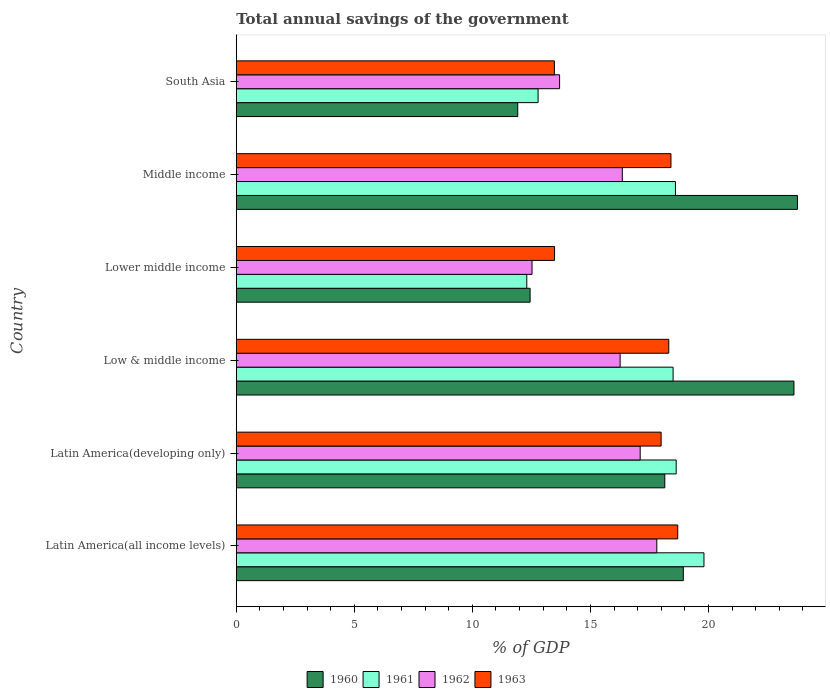How many groups of bars are there?
Offer a terse response. 6. Are the number of bars on each tick of the Y-axis equal?
Provide a short and direct response. Yes. How many bars are there on the 5th tick from the top?
Provide a short and direct response. 4. How many bars are there on the 1st tick from the bottom?
Offer a very short reply. 4. In how many cases, is the number of bars for a given country not equal to the number of legend labels?
Your answer should be very brief. 0. What is the total annual savings of the government in 1961 in Latin America(developing only)?
Give a very brief answer. 18.63. Across all countries, what is the maximum total annual savings of the government in 1963?
Provide a short and direct response. 18.7. Across all countries, what is the minimum total annual savings of the government in 1962?
Offer a terse response. 12.53. In which country was the total annual savings of the government in 1962 minimum?
Make the answer very short. Lower middle income. What is the total total annual savings of the government in 1963 in the graph?
Your answer should be compact. 100.38. What is the difference between the total annual savings of the government in 1963 in Latin America(all income levels) and that in Low & middle income?
Provide a short and direct response. 0.38. What is the difference between the total annual savings of the government in 1960 in Latin America(developing only) and the total annual savings of the government in 1961 in Lower middle income?
Your response must be concise. 5.85. What is the average total annual savings of the government in 1963 per country?
Provide a succinct answer. 16.73. What is the difference between the total annual savings of the government in 1960 and total annual savings of the government in 1963 in Low & middle income?
Offer a terse response. 5.3. In how many countries, is the total annual savings of the government in 1960 greater than 1 %?
Ensure brevity in your answer.  6. What is the ratio of the total annual savings of the government in 1963 in Lower middle income to that in Middle income?
Offer a very short reply. 0.73. What is the difference between the highest and the second highest total annual savings of the government in 1963?
Your answer should be compact. 0.29. What is the difference between the highest and the lowest total annual savings of the government in 1960?
Keep it short and to the point. 11.85. Is the sum of the total annual savings of the government in 1960 in Latin America(all income levels) and Latin America(developing only) greater than the maximum total annual savings of the government in 1962 across all countries?
Offer a very short reply. Yes. What does the 1st bar from the top in Latin America(all income levels) represents?
Your response must be concise. 1963. What does the 2nd bar from the bottom in Lower middle income represents?
Ensure brevity in your answer.  1961. Is it the case that in every country, the sum of the total annual savings of the government in 1962 and total annual savings of the government in 1963 is greater than the total annual savings of the government in 1960?
Offer a very short reply. Yes. How many countries are there in the graph?
Provide a short and direct response. 6. What is the difference between two consecutive major ticks on the X-axis?
Your answer should be compact. 5. Are the values on the major ticks of X-axis written in scientific E-notation?
Provide a short and direct response. No. Does the graph contain any zero values?
Provide a succinct answer. No. Does the graph contain grids?
Your answer should be very brief. No. Where does the legend appear in the graph?
Provide a succinct answer. Bottom center. How many legend labels are there?
Keep it short and to the point. 4. How are the legend labels stacked?
Your response must be concise. Horizontal. What is the title of the graph?
Your answer should be compact. Total annual savings of the government. Does "1960" appear as one of the legend labels in the graph?
Make the answer very short. Yes. What is the label or title of the X-axis?
Give a very brief answer. % of GDP. What is the label or title of the Y-axis?
Your response must be concise. Country. What is the % of GDP of 1960 in Latin America(all income levels)?
Your answer should be compact. 18.93. What is the % of GDP of 1961 in Latin America(all income levels)?
Make the answer very short. 19.81. What is the % of GDP of 1962 in Latin America(all income levels)?
Ensure brevity in your answer.  17.81. What is the % of GDP in 1963 in Latin America(all income levels)?
Give a very brief answer. 18.7. What is the % of GDP in 1960 in Latin America(developing only)?
Give a very brief answer. 18.15. What is the % of GDP of 1961 in Latin America(developing only)?
Your response must be concise. 18.63. What is the % of GDP of 1962 in Latin America(developing only)?
Offer a terse response. 17.11. What is the % of GDP of 1963 in Latin America(developing only)?
Give a very brief answer. 17.99. What is the % of GDP in 1960 in Low & middle income?
Offer a terse response. 23.62. What is the % of GDP of 1961 in Low & middle income?
Make the answer very short. 18.5. What is the % of GDP in 1962 in Low & middle income?
Provide a short and direct response. 16.26. What is the % of GDP of 1963 in Low & middle income?
Your answer should be compact. 18.32. What is the % of GDP of 1960 in Lower middle income?
Ensure brevity in your answer.  12.45. What is the % of GDP in 1961 in Lower middle income?
Your answer should be compact. 12.3. What is the % of GDP in 1962 in Lower middle income?
Offer a terse response. 12.53. What is the % of GDP of 1963 in Lower middle income?
Provide a succinct answer. 13.48. What is the % of GDP of 1960 in Middle income?
Ensure brevity in your answer.  23.77. What is the % of GDP of 1961 in Middle income?
Provide a succinct answer. 18.6. What is the % of GDP of 1962 in Middle income?
Offer a very short reply. 16.35. What is the % of GDP in 1963 in Middle income?
Ensure brevity in your answer.  18.41. What is the % of GDP in 1960 in South Asia?
Provide a short and direct response. 11.92. What is the % of GDP of 1961 in South Asia?
Provide a succinct answer. 12.78. What is the % of GDP of 1962 in South Asia?
Give a very brief answer. 13.69. What is the % of GDP of 1963 in South Asia?
Make the answer very short. 13.48. Across all countries, what is the maximum % of GDP in 1960?
Your response must be concise. 23.77. Across all countries, what is the maximum % of GDP in 1961?
Give a very brief answer. 19.81. Across all countries, what is the maximum % of GDP in 1962?
Ensure brevity in your answer.  17.81. Across all countries, what is the maximum % of GDP in 1963?
Provide a short and direct response. 18.7. Across all countries, what is the minimum % of GDP of 1960?
Offer a terse response. 11.92. Across all countries, what is the minimum % of GDP of 1961?
Give a very brief answer. 12.3. Across all countries, what is the minimum % of GDP in 1962?
Offer a very short reply. 12.53. Across all countries, what is the minimum % of GDP in 1963?
Your answer should be very brief. 13.48. What is the total % of GDP of 1960 in the graph?
Ensure brevity in your answer.  108.84. What is the total % of GDP of 1961 in the graph?
Ensure brevity in your answer.  100.64. What is the total % of GDP in 1962 in the graph?
Your response must be concise. 93.75. What is the total % of GDP of 1963 in the graph?
Keep it short and to the point. 100.38. What is the difference between the % of GDP of 1960 in Latin America(all income levels) and that in Latin America(developing only)?
Your answer should be compact. 0.78. What is the difference between the % of GDP of 1961 in Latin America(all income levels) and that in Latin America(developing only)?
Make the answer very short. 1.18. What is the difference between the % of GDP of 1962 in Latin America(all income levels) and that in Latin America(developing only)?
Offer a very short reply. 0.7. What is the difference between the % of GDP in 1963 in Latin America(all income levels) and that in Latin America(developing only)?
Keep it short and to the point. 0.7. What is the difference between the % of GDP of 1960 in Latin America(all income levels) and that in Low & middle income?
Provide a succinct answer. -4.69. What is the difference between the % of GDP of 1961 in Latin America(all income levels) and that in Low & middle income?
Offer a terse response. 1.31. What is the difference between the % of GDP in 1962 in Latin America(all income levels) and that in Low & middle income?
Your answer should be very brief. 1.55. What is the difference between the % of GDP of 1963 in Latin America(all income levels) and that in Low & middle income?
Your answer should be very brief. 0.38. What is the difference between the % of GDP in 1960 in Latin America(all income levels) and that in Lower middle income?
Give a very brief answer. 6.49. What is the difference between the % of GDP in 1961 in Latin America(all income levels) and that in Lower middle income?
Keep it short and to the point. 7.5. What is the difference between the % of GDP in 1962 in Latin America(all income levels) and that in Lower middle income?
Provide a succinct answer. 5.28. What is the difference between the % of GDP of 1963 in Latin America(all income levels) and that in Lower middle income?
Keep it short and to the point. 5.22. What is the difference between the % of GDP in 1960 in Latin America(all income levels) and that in Middle income?
Your answer should be very brief. -4.83. What is the difference between the % of GDP in 1961 in Latin America(all income levels) and that in Middle income?
Your answer should be very brief. 1.21. What is the difference between the % of GDP in 1962 in Latin America(all income levels) and that in Middle income?
Offer a terse response. 1.46. What is the difference between the % of GDP in 1963 in Latin America(all income levels) and that in Middle income?
Your answer should be very brief. 0.29. What is the difference between the % of GDP in 1960 in Latin America(all income levels) and that in South Asia?
Keep it short and to the point. 7.01. What is the difference between the % of GDP in 1961 in Latin America(all income levels) and that in South Asia?
Offer a terse response. 7.03. What is the difference between the % of GDP of 1962 in Latin America(all income levels) and that in South Asia?
Give a very brief answer. 4.12. What is the difference between the % of GDP in 1963 in Latin America(all income levels) and that in South Asia?
Make the answer very short. 5.22. What is the difference between the % of GDP in 1960 in Latin America(developing only) and that in Low & middle income?
Keep it short and to the point. -5.47. What is the difference between the % of GDP in 1961 in Latin America(developing only) and that in Low & middle income?
Your answer should be very brief. 0.13. What is the difference between the % of GDP of 1962 in Latin America(developing only) and that in Low & middle income?
Your response must be concise. 0.85. What is the difference between the % of GDP in 1963 in Latin America(developing only) and that in Low & middle income?
Keep it short and to the point. -0.32. What is the difference between the % of GDP of 1960 in Latin America(developing only) and that in Lower middle income?
Your response must be concise. 5.7. What is the difference between the % of GDP in 1961 in Latin America(developing only) and that in Lower middle income?
Your answer should be very brief. 6.33. What is the difference between the % of GDP of 1962 in Latin America(developing only) and that in Lower middle income?
Your answer should be compact. 4.58. What is the difference between the % of GDP of 1963 in Latin America(developing only) and that in Lower middle income?
Your answer should be very brief. 4.51. What is the difference between the % of GDP of 1960 in Latin America(developing only) and that in Middle income?
Offer a very short reply. -5.62. What is the difference between the % of GDP in 1961 in Latin America(developing only) and that in Middle income?
Keep it short and to the point. 0.03. What is the difference between the % of GDP of 1962 in Latin America(developing only) and that in Middle income?
Make the answer very short. 0.76. What is the difference between the % of GDP in 1963 in Latin America(developing only) and that in Middle income?
Provide a succinct answer. -0.42. What is the difference between the % of GDP of 1960 in Latin America(developing only) and that in South Asia?
Provide a succinct answer. 6.23. What is the difference between the % of GDP of 1961 in Latin America(developing only) and that in South Asia?
Your answer should be very brief. 5.85. What is the difference between the % of GDP in 1962 in Latin America(developing only) and that in South Asia?
Make the answer very short. 3.41. What is the difference between the % of GDP in 1963 in Latin America(developing only) and that in South Asia?
Give a very brief answer. 4.52. What is the difference between the % of GDP of 1960 in Low & middle income and that in Lower middle income?
Offer a very short reply. 11.18. What is the difference between the % of GDP in 1961 in Low & middle income and that in Lower middle income?
Your response must be concise. 6.2. What is the difference between the % of GDP of 1962 in Low & middle income and that in Lower middle income?
Your answer should be very brief. 3.73. What is the difference between the % of GDP in 1963 in Low & middle income and that in Lower middle income?
Your answer should be compact. 4.84. What is the difference between the % of GDP in 1960 in Low & middle income and that in Middle income?
Provide a succinct answer. -0.15. What is the difference between the % of GDP in 1961 in Low & middle income and that in Middle income?
Make the answer very short. -0.1. What is the difference between the % of GDP in 1962 in Low & middle income and that in Middle income?
Your response must be concise. -0.09. What is the difference between the % of GDP of 1963 in Low & middle income and that in Middle income?
Ensure brevity in your answer.  -0.09. What is the difference between the % of GDP in 1960 in Low & middle income and that in South Asia?
Provide a short and direct response. 11.7. What is the difference between the % of GDP in 1961 in Low & middle income and that in South Asia?
Your response must be concise. 5.72. What is the difference between the % of GDP of 1962 in Low & middle income and that in South Asia?
Keep it short and to the point. 2.56. What is the difference between the % of GDP of 1963 in Low & middle income and that in South Asia?
Give a very brief answer. 4.84. What is the difference between the % of GDP in 1960 in Lower middle income and that in Middle income?
Provide a short and direct response. -11.32. What is the difference between the % of GDP of 1961 in Lower middle income and that in Middle income?
Give a very brief answer. -6.3. What is the difference between the % of GDP in 1962 in Lower middle income and that in Middle income?
Provide a short and direct response. -3.82. What is the difference between the % of GDP in 1963 in Lower middle income and that in Middle income?
Your answer should be very brief. -4.93. What is the difference between the % of GDP of 1960 in Lower middle income and that in South Asia?
Offer a very short reply. 0.52. What is the difference between the % of GDP of 1961 in Lower middle income and that in South Asia?
Provide a succinct answer. -0.48. What is the difference between the % of GDP of 1962 in Lower middle income and that in South Asia?
Keep it short and to the point. -1.17. What is the difference between the % of GDP in 1963 in Lower middle income and that in South Asia?
Offer a very short reply. 0.01. What is the difference between the % of GDP in 1960 in Middle income and that in South Asia?
Your response must be concise. 11.85. What is the difference between the % of GDP in 1961 in Middle income and that in South Asia?
Your response must be concise. 5.82. What is the difference between the % of GDP in 1962 in Middle income and that in South Asia?
Provide a short and direct response. 2.66. What is the difference between the % of GDP in 1963 in Middle income and that in South Asia?
Keep it short and to the point. 4.94. What is the difference between the % of GDP of 1960 in Latin America(all income levels) and the % of GDP of 1961 in Latin America(developing only)?
Ensure brevity in your answer.  0.3. What is the difference between the % of GDP in 1960 in Latin America(all income levels) and the % of GDP in 1962 in Latin America(developing only)?
Your answer should be very brief. 1.83. What is the difference between the % of GDP of 1960 in Latin America(all income levels) and the % of GDP of 1963 in Latin America(developing only)?
Your response must be concise. 0.94. What is the difference between the % of GDP of 1961 in Latin America(all income levels) and the % of GDP of 1962 in Latin America(developing only)?
Ensure brevity in your answer.  2.7. What is the difference between the % of GDP in 1961 in Latin America(all income levels) and the % of GDP in 1963 in Latin America(developing only)?
Your answer should be very brief. 1.81. What is the difference between the % of GDP in 1962 in Latin America(all income levels) and the % of GDP in 1963 in Latin America(developing only)?
Your answer should be very brief. -0.18. What is the difference between the % of GDP of 1960 in Latin America(all income levels) and the % of GDP of 1961 in Low & middle income?
Provide a short and direct response. 0.43. What is the difference between the % of GDP in 1960 in Latin America(all income levels) and the % of GDP in 1962 in Low & middle income?
Your answer should be very brief. 2.68. What is the difference between the % of GDP in 1960 in Latin America(all income levels) and the % of GDP in 1963 in Low & middle income?
Give a very brief answer. 0.62. What is the difference between the % of GDP in 1961 in Latin America(all income levels) and the % of GDP in 1962 in Low & middle income?
Ensure brevity in your answer.  3.55. What is the difference between the % of GDP of 1961 in Latin America(all income levels) and the % of GDP of 1963 in Low & middle income?
Your answer should be compact. 1.49. What is the difference between the % of GDP of 1962 in Latin America(all income levels) and the % of GDP of 1963 in Low & middle income?
Provide a short and direct response. -0.51. What is the difference between the % of GDP of 1960 in Latin America(all income levels) and the % of GDP of 1961 in Lower middle income?
Provide a succinct answer. 6.63. What is the difference between the % of GDP in 1960 in Latin America(all income levels) and the % of GDP in 1962 in Lower middle income?
Keep it short and to the point. 6.41. What is the difference between the % of GDP of 1960 in Latin America(all income levels) and the % of GDP of 1963 in Lower middle income?
Provide a short and direct response. 5.45. What is the difference between the % of GDP in 1961 in Latin America(all income levels) and the % of GDP in 1962 in Lower middle income?
Offer a terse response. 7.28. What is the difference between the % of GDP in 1961 in Latin America(all income levels) and the % of GDP in 1963 in Lower middle income?
Keep it short and to the point. 6.33. What is the difference between the % of GDP in 1962 in Latin America(all income levels) and the % of GDP in 1963 in Lower middle income?
Make the answer very short. 4.33. What is the difference between the % of GDP of 1960 in Latin America(all income levels) and the % of GDP of 1961 in Middle income?
Your response must be concise. 0.33. What is the difference between the % of GDP of 1960 in Latin America(all income levels) and the % of GDP of 1962 in Middle income?
Provide a short and direct response. 2.58. What is the difference between the % of GDP in 1960 in Latin America(all income levels) and the % of GDP in 1963 in Middle income?
Ensure brevity in your answer.  0.52. What is the difference between the % of GDP of 1961 in Latin America(all income levels) and the % of GDP of 1962 in Middle income?
Your answer should be compact. 3.46. What is the difference between the % of GDP in 1961 in Latin America(all income levels) and the % of GDP in 1963 in Middle income?
Make the answer very short. 1.4. What is the difference between the % of GDP of 1962 in Latin America(all income levels) and the % of GDP of 1963 in Middle income?
Your answer should be compact. -0.6. What is the difference between the % of GDP of 1960 in Latin America(all income levels) and the % of GDP of 1961 in South Asia?
Provide a short and direct response. 6.15. What is the difference between the % of GDP in 1960 in Latin America(all income levels) and the % of GDP in 1962 in South Asia?
Ensure brevity in your answer.  5.24. What is the difference between the % of GDP of 1960 in Latin America(all income levels) and the % of GDP of 1963 in South Asia?
Make the answer very short. 5.46. What is the difference between the % of GDP in 1961 in Latin America(all income levels) and the % of GDP in 1962 in South Asia?
Your answer should be very brief. 6.11. What is the difference between the % of GDP in 1961 in Latin America(all income levels) and the % of GDP in 1963 in South Asia?
Your answer should be compact. 6.33. What is the difference between the % of GDP of 1962 in Latin America(all income levels) and the % of GDP of 1963 in South Asia?
Provide a short and direct response. 4.34. What is the difference between the % of GDP of 1960 in Latin America(developing only) and the % of GDP of 1961 in Low & middle income?
Provide a succinct answer. -0.35. What is the difference between the % of GDP of 1960 in Latin America(developing only) and the % of GDP of 1962 in Low & middle income?
Keep it short and to the point. 1.89. What is the difference between the % of GDP in 1960 in Latin America(developing only) and the % of GDP in 1963 in Low & middle income?
Give a very brief answer. -0.17. What is the difference between the % of GDP of 1961 in Latin America(developing only) and the % of GDP of 1962 in Low & middle income?
Ensure brevity in your answer.  2.37. What is the difference between the % of GDP of 1961 in Latin America(developing only) and the % of GDP of 1963 in Low & middle income?
Give a very brief answer. 0.31. What is the difference between the % of GDP of 1962 in Latin America(developing only) and the % of GDP of 1963 in Low & middle income?
Your response must be concise. -1.21. What is the difference between the % of GDP in 1960 in Latin America(developing only) and the % of GDP in 1961 in Lower middle income?
Offer a very short reply. 5.85. What is the difference between the % of GDP of 1960 in Latin America(developing only) and the % of GDP of 1962 in Lower middle income?
Your response must be concise. 5.62. What is the difference between the % of GDP in 1960 in Latin America(developing only) and the % of GDP in 1963 in Lower middle income?
Your answer should be very brief. 4.67. What is the difference between the % of GDP in 1961 in Latin America(developing only) and the % of GDP in 1962 in Lower middle income?
Give a very brief answer. 6.11. What is the difference between the % of GDP of 1961 in Latin America(developing only) and the % of GDP of 1963 in Lower middle income?
Keep it short and to the point. 5.15. What is the difference between the % of GDP of 1962 in Latin America(developing only) and the % of GDP of 1963 in Lower middle income?
Provide a short and direct response. 3.63. What is the difference between the % of GDP in 1960 in Latin America(developing only) and the % of GDP in 1961 in Middle income?
Keep it short and to the point. -0.45. What is the difference between the % of GDP of 1960 in Latin America(developing only) and the % of GDP of 1962 in Middle income?
Your response must be concise. 1.8. What is the difference between the % of GDP in 1960 in Latin America(developing only) and the % of GDP in 1963 in Middle income?
Give a very brief answer. -0.26. What is the difference between the % of GDP in 1961 in Latin America(developing only) and the % of GDP in 1962 in Middle income?
Your answer should be very brief. 2.28. What is the difference between the % of GDP of 1961 in Latin America(developing only) and the % of GDP of 1963 in Middle income?
Your answer should be compact. 0.22. What is the difference between the % of GDP in 1962 in Latin America(developing only) and the % of GDP in 1963 in Middle income?
Provide a succinct answer. -1.3. What is the difference between the % of GDP of 1960 in Latin America(developing only) and the % of GDP of 1961 in South Asia?
Offer a terse response. 5.37. What is the difference between the % of GDP of 1960 in Latin America(developing only) and the % of GDP of 1962 in South Asia?
Your answer should be compact. 4.46. What is the difference between the % of GDP of 1960 in Latin America(developing only) and the % of GDP of 1963 in South Asia?
Offer a very short reply. 4.67. What is the difference between the % of GDP of 1961 in Latin America(developing only) and the % of GDP of 1962 in South Asia?
Your answer should be very brief. 4.94. What is the difference between the % of GDP in 1961 in Latin America(developing only) and the % of GDP in 1963 in South Asia?
Ensure brevity in your answer.  5.16. What is the difference between the % of GDP of 1962 in Latin America(developing only) and the % of GDP of 1963 in South Asia?
Your answer should be very brief. 3.63. What is the difference between the % of GDP of 1960 in Low & middle income and the % of GDP of 1961 in Lower middle income?
Offer a very short reply. 11.32. What is the difference between the % of GDP in 1960 in Low & middle income and the % of GDP in 1962 in Lower middle income?
Your answer should be compact. 11.09. What is the difference between the % of GDP in 1960 in Low & middle income and the % of GDP in 1963 in Lower middle income?
Keep it short and to the point. 10.14. What is the difference between the % of GDP in 1961 in Low & middle income and the % of GDP in 1962 in Lower middle income?
Offer a very short reply. 5.97. What is the difference between the % of GDP of 1961 in Low & middle income and the % of GDP of 1963 in Lower middle income?
Provide a succinct answer. 5.02. What is the difference between the % of GDP in 1962 in Low & middle income and the % of GDP in 1963 in Lower middle income?
Give a very brief answer. 2.78. What is the difference between the % of GDP of 1960 in Low & middle income and the % of GDP of 1961 in Middle income?
Ensure brevity in your answer.  5.02. What is the difference between the % of GDP in 1960 in Low & middle income and the % of GDP in 1962 in Middle income?
Give a very brief answer. 7.27. What is the difference between the % of GDP of 1960 in Low & middle income and the % of GDP of 1963 in Middle income?
Make the answer very short. 5.21. What is the difference between the % of GDP of 1961 in Low & middle income and the % of GDP of 1962 in Middle income?
Make the answer very short. 2.15. What is the difference between the % of GDP in 1961 in Low & middle income and the % of GDP in 1963 in Middle income?
Offer a very short reply. 0.09. What is the difference between the % of GDP of 1962 in Low & middle income and the % of GDP of 1963 in Middle income?
Offer a terse response. -2.15. What is the difference between the % of GDP in 1960 in Low & middle income and the % of GDP in 1961 in South Asia?
Give a very brief answer. 10.84. What is the difference between the % of GDP of 1960 in Low & middle income and the % of GDP of 1962 in South Asia?
Your answer should be very brief. 9.93. What is the difference between the % of GDP in 1960 in Low & middle income and the % of GDP in 1963 in South Asia?
Ensure brevity in your answer.  10.15. What is the difference between the % of GDP in 1961 in Low & middle income and the % of GDP in 1962 in South Asia?
Provide a succinct answer. 4.81. What is the difference between the % of GDP in 1961 in Low & middle income and the % of GDP in 1963 in South Asia?
Provide a short and direct response. 5.03. What is the difference between the % of GDP of 1962 in Low & middle income and the % of GDP of 1963 in South Asia?
Provide a succinct answer. 2.78. What is the difference between the % of GDP in 1960 in Lower middle income and the % of GDP in 1961 in Middle income?
Keep it short and to the point. -6.16. What is the difference between the % of GDP in 1960 in Lower middle income and the % of GDP in 1962 in Middle income?
Your answer should be compact. -3.9. What is the difference between the % of GDP in 1960 in Lower middle income and the % of GDP in 1963 in Middle income?
Ensure brevity in your answer.  -5.97. What is the difference between the % of GDP in 1961 in Lower middle income and the % of GDP in 1962 in Middle income?
Give a very brief answer. -4.05. What is the difference between the % of GDP of 1961 in Lower middle income and the % of GDP of 1963 in Middle income?
Give a very brief answer. -6.11. What is the difference between the % of GDP of 1962 in Lower middle income and the % of GDP of 1963 in Middle income?
Offer a terse response. -5.88. What is the difference between the % of GDP of 1960 in Lower middle income and the % of GDP of 1961 in South Asia?
Your answer should be very brief. -0.34. What is the difference between the % of GDP of 1960 in Lower middle income and the % of GDP of 1962 in South Asia?
Make the answer very short. -1.25. What is the difference between the % of GDP in 1960 in Lower middle income and the % of GDP in 1963 in South Asia?
Make the answer very short. -1.03. What is the difference between the % of GDP in 1961 in Lower middle income and the % of GDP in 1962 in South Asia?
Offer a terse response. -1.39. What is the difference between the % of GDP in 1961 in Lower middle income and the % of GDP in 1963 in South Asia?
Offer a terse response. -1.17. What is the difference between the % of GDP in 1962 in Lower middle income and the % of GDP in 1963 in South Asia?
Provide a succinct answer. -0.95. What is the difference between the % of GDP of 1960 in Middle income and the % of GDP of 1961 in South Asia?
Provide a short and direct response. 10.98. What is the difference between the % of GDP in 1960 in Middle income and the % of GDP in 1962 in South Asia?
Ensure brevity in your answer.  10.07. What is the difference between the % of GDP of 1960 in Middle income and the % of GDP of 1963 in South Asia?
Make the answer very short. 10.29. What is the difference between the % of GDP in 1961 in Middle income and the % of GDP in 1962 in South Asia?
Offer a terse response. 4.91. What is the difference between the % of GDP of 1961 in Middle income and the % of GDP of 1963 in South Asia?
Provide a short and direct response. 5.13. What is the difference between the % of GDP in 1962 in Middle income and the % of GDP in 1963 in South Asia?
Your answer should be very brief. 2.88. What is the average % of GDP in 1960 per country?
Offer a terse response. 18.14. What is the average % of GDP of 1961 per country?
Provide a short and direct response. 16.77. What is the average % of GDP of 1962 per country?
Your answer should be very brief. 15.63. What is the average % of GDP of 1963 per country?
Keep it short and to the point. 16.73. What is the difference between the % of GDP of 1960 and % of GDP of 1961 in Latin America(all income levels)?
Provide a succinct answer. -0.87. What is the difference between the % of GDP in 1960 and % of GDP in 1962 in Latin America(all income levels)?
Ensure brevity in your answer.  1.12. What is the difference between the % of GDP of 1960 and % of GDP of 1963 in Latin America(all income levels)?
Offer a very short reply. 0.24. What is the difference between the % of GDP in 1961 and % of GDP in 1962 in Latin America(all income levels)?
Provide a succinct answer. 2. What is the difference between the % of GDP in 1961 and % of GDP in 1963 in Latin America(all income levels)?
Ensure brevity in your answer.  1.11. What is the difference between the % of GDP of 1962 and % of GDP of 1963 in Latin America(all income levels)?
Provide a short and direct response. -0.89. What is the difference between the % of GDP in 1960 and % of GDP in 1961 in Latin America(developing only)?
Give a very brief answer. -0.48. What is the difference between the % of GDP in 1960 and % of GDP in 1962 in Latin America(developing only)?
Make the answer very short. 1.04. What is the difference between the % of GDP in 1960 and % of GDP in 1963 in Latin America(developing only)?
Your response must be concise. 0.16. What is the difference between the % of GDP in 1961 and % of GDP in 1962 in Latin America(developing only)?
Your answer should be very brief. 1.52. What is the difference between the % of GDP of 1961 and % of GDP of 1963 in Latin America(developing only)?
Offer a terse response. 0.64. What is the difference between the % of GDP in 1962 and % of GDP in 1963 in Latin America(developing only)?
Your answer should be very brief. -0.89. What is the difference between the % of GDP of 1960 and % of GDP of 1961 in Low & middle income?
Give a very brief answer. 5.12. What is the difference between the % of GDP of 1960 and % of GDP of 1962 in Low & middle income?
Give a very brief answer. 7.36. What is the difference between the % of GDP of 1960 and % of GDP of 1963 in Low & middle income?
Offer a very short reply. 5.3. What is the difference between the % of GDP in 1961 and % of GDP in 1962 in Low & middle income?
Offer a very short reply. 2.24. What is the difference between the % of GDP in 1961 and % of GDP in 1963 in Low & middle income?
Offer a terse response. 0.18. What is the difference between the % of GDP of 1962 and % of GDP of 1963 in Low & middle income?
Your answer should be very brief. -2.06. What is the difference between the % of GDP of 1960 and % of GDP of 1961 in Lower middle income?
Offer a terse response. 0.14. What is the difference between the % of GDP in 1960 and % of GDP in 1962 in Lower middle income?
Keep it short and to the point. -0.08. What is the difference between the % of GDP of 1960 and % of GDP of 1963 in Lower middle income?
Provide a succinct answer. -1.04. What is the difference between the % of GDP in 1961 and % of GDP in 1962 in Lower middle income?
Provide a short and direct response. -0.22. What is the difference between the % of GDP of 1961 and % of GDP of 1963 in Lower middle income?
Provide a short and direct response. -1.18. What is the difference between the % of GDP in 1962 and % of GDP in 1963 in Lower middle income?
Your response must be concise. -0.95. What is the difference between the % of GDP in 1960 and % of GDP in 1961 in Middle income?
Offer a very short reply. 5.17. What is the difference between the % of GDP in 1960 and % of GDP in 1962 in Middle income?
Keep it short and to the point. 7.42. What is the difference between the % of GDP in 1960 and % of GDP in 1963 in Middle income?
Offer a very short reply. 5.36. What is the difference between the % of GDP of 1961 and % of GDP of 1962 in Middle income?
Your answer should be very brief. 2.25. What is the difference between the % of GDP of 1961 and % of GDP of 1963 in Middle income?
Your answer should be compact. 0.19. What is the difference between the % of GDP in 1962 and % of GDP in 1963 in Middle income?
Your answer should be compact. -2.06. What is the difference between the % of GDP in 1960 and % of GDP in 1961 in South Asia?
Make the answer very short. -0.86. What is the difference between the % of GDP of 1960 and % of GDP of 1962 in South Asia?
Your response must be concise. -1.77. What is the difference between the % of GDP in 1960 and % of GDP in 1963 in South Asia?
Offer a very short reply. -1.55. What is the difference between the % of GDP of 1961 and % of GDP of 1962 in South Asia?
Give a very brief answer. -0.91. What is the difference between the % of GDP of 1961 and % of GDP of 1963 in South Asia?
Offer a terse response. -0.69. What is the difference between the % of GDP of 1962 and % of GDP of 1963 in South Asia?
Your response must be concise. 0.22. What is the ratio of the % of GDP of 1960 in Latin America(all income levels) to that in Latin America(developing only)?
Your response must be concise. 1.04. What is the ratio of the % of GDP in 1961 in Latin America(all income levels) to that in Latin America(developing only)?
Your answer should be very brief. 1.06. What is the ratio of the % of GDP of 1962 in Latin America(all income levels) to that in Latin America(developing only)?
Give a very brief answer. 1.04. What is the ratio of the % of GDP in 1963 in Latin America(all income levels) to that in Latin America(developing only)?
Make the answer very short. 1.04. What is the ratio of the % of GDP of 1960 in Latin America(all income levels) to that in Low & middle income?
Your answer should be very brief. 0.8. What is the ratio of the % of GDP in 1961 in Latin America(all income levels) to that in Low & middle income?
Your answer should be very brief. 1.07. What is the ratio of the % of GDP in 1962 in Latin America(all income levels) to that in Low & middle income?
Provide a short and direct response. 1.1. What is the ratio of the % of GDP of 1963 in Latin America(all income levels) to that in Low & middle income?
Make the answer very short. 1.02. What is the ratio of the % of GDP in 1960 in Latin America(all income levels) to that in Lower middle income?
Provide a succinct answer. 1.52. What is the ratio of the % of GDP in 1961 in Latin America(all income levels) to that in Lower middle income?
Give a very brief answer. 1.61. What is the ratio of the % of GDP of 1962 in Latin America(all income levels) to that in Lower middle income?
Offer a terse response. 1.42. What is the ratio of the % of GDP of 1963 in Latin America(all income levels) to that in Lower middle income?
Offer a terse response. 1.39. What is the ratio of the % of GDP of 1960 in Latin America(all income levels) to that in Middle income?
Provide a succinct answer. 0.8. What is the ratio of the % of GDP in 1961 in Latin America(all income levels) to that in Middle income?
Ensure brevity in your answer.  1.06. What is the ratio of the % of GDP of 1962 in Latin America(all income levels) to that in Middle income?
Your answer should be very brief. 1.09. What is the ratio of the % of GDP in 1963 in Latin America(all income levels) to that in Middle income?
Make the answer very short. 1.02. What is the ratio of the % of GDP of 1960 in Latin America(all income levels) to that in South Asia?
Provide a short and direct response. 1.59. What is the ratio of the % of GDP in 1961 in Latin America(all income levels) to that in South Asia?
Offer a terse response. 1.55. What is the ratio of the % of GDP of 1962 in Latin America(all income levels) to that in South Asia?
Provide a short and direct response. 1.3. What is the ratio of the % of GDP in 1963 in Latin America(all income levels) to that in South Asia?
Provide a short and direct response. 1.39. What is the ratio of the % of GDP in 1960 in Latin America(developing only) to that in Low & middle income?
Your answer should be very brief. 0.77. What is the ratio of the % of GDP in 1961 in Latin America(developing only) to that in Low & middle income?
Offer a very short reply. 1.01. What is the ratio of the % of GDP in 1962 in Latin America(developing only) to that in Low & middle income?
Your answer should be compact. 1.05. What is the ratio of the % of GDP of 1963 in Latin America(developing only) to that in Low & middle income?
Offer a very short reply. 0.98. What is the ratio of the % of GDP of 1960 in Latin America(developing only) to that in Lower middle income?
Provide a succinct answer. 1.46. What is the ratio of the % of GDP of 1961 in Latin America(developing only) to that in Lower middle income?
Offer a terse response. 1.51. What is the ratio of the % of GDP in 1962 in Latin America(developing only) to that in Lower middle income?
Give a very brief answer. 1.37. What is the ratio of the % of GDP of 1963 in Latin America(developing only) to that in Lower middle income?
Offer a terse response. 1.33. What is the ratio of the % of GDP in 1960 in Latin America(developing only) to that in Middle income?
Keep it short and to the point. 0.76. What is the ratio of the % of GDP of 1962 in Latin America(developing only) to that in Middle income?
Your answer should be very brief. 1.05. What is the ratio of the % of GDP of 1963 in Latin America(developing only) to that in Middle income?
Give a very brief answer. 0.98. What is the ratio of the % of GDP of 1960 in Latin America(developing only) to that in South Asia?
Give a very brief answer. 1.52. What is the ratio of the % of GDP in 1961 in Latin America(developing only) to that in South Asia?
Your answer should be very brief. 1.46. What is the ratio of the % of GDP of 1962 in Latin America(developing only) to that in South Asia?
Offer a terse response. 1.25. What is the ratio of the % of GDP of 1963 in Latin America(developing only) to that in South Asia?
Give a very brief answer. 1.34. What is the ratio of the % of GDP in 1960 in Low & middle income to that in Lower middle income?
Your response must be concise. 1.9. What is the ratio of the % of GDP in 1961 in Low & middle income to that in Lower middle income?
Your answer should be compact. 1.5. What is the ratio of the % of GDP in 1962 in Low & middle income to that in Lower middle income?
Give a very brief answer. 1.3. What is the ratio of the % of GDP in 1963 in Low & middle income to that in Lower middle income?
Offer a terse response. 1.36. What is the ratio of the % of GDP of 1961 in Low & middle income to that in Middle income?
Your response must be concise. 0.99. What is the ratio of the % of GDP in 1963 in Low & middle income to that in Middle income?
Keep it short and to the point. 0.99. What is the ratio of the % of GDP in 1960 in Low & middle income to that in South Asia?
Make the answer very short. 1.98. What is the ratio of the % of GDP in 1961 in Low & middle income to that in South Asia?
Offer a very short reply. 1.45. What is the ratio of the % of GDP of 1962 in Low & middle income to that in South Asia?
Your answer should be very brief. 1.19. What is the ratio of the % of GDP in 1963 in Low & middle income to that in South Asia?
Keep it short and to the point. 1.36. What is the ratio of the % of GDP in 1960 in Lower middle income to that in Middle income?
Make the answer very short. 0.52. What is the ratio of the % of GDP in 1961 in Lower middle income to that in Middle income?
Keep it short and to the point. 0.66. What is the ratio of the % of GDP in 1962 in Lower middle income to that in Middle income?
Give a very brief answer. 0.77. What is the ratio of the % of GDP of 1963 in Lower middle income to that in Middle income?
Make the answer very short. 0.73. What is the ratio of the % of GDP of 1960 in Lower middle income to that in South Asia?
Keep it short and to the point. 1.04. What is the ratio of the % of GDP of 1961 in Lower middle income to that in South Asia?
Offer a very short reply. 0.96. What is the ratio of the % of GDP in 1962 in Lower middle income to that in South Asia?
Your answer should be very brief. 0.91. What is the ratio of the % of GDP in 1960 in Middle income to that in South Asia?
Your answer should be very brief. 1.99. What is the ratio of the % of GDP of 1961 in Middle income to that in South Asia?
Ensure brevity in your answer.  1.46. What is the ratio of the % of GDP of 1962 in Middle income to that in South Asia?
Your answer should be compact. 1.19. What is the ratio of the % of GDP of 1963 in Middle income to that in South Asia?
Your response must be concise. 1.37. What is the difference between the highest and the second highest % of GDP in 1960?
Give a very brief answer. 0.15. What is the difference between the highest and the second highest % of GDP of 1961?
Make the answer very short. 1.18. What is the difference between the highest and the second highest % of GDP in 1962?
Provide a succinct answer. 0.7. What is the difference between the highest and the second highest % of GDP of 1963?
Your answer should be very brief. 0.29. What is the difference between the highest and the lowest % of GDP in 1960?
Your answer should be very brief. 11.85. What is the difference between the highest and the lowest % of GDP in 1961?
Your response must be concise. 7.5. What is the difference between the highest and the lowest % of GDP in 1962?
Offer a terse response. 5.28. What is the difference between the highest and the lowest % of GDP in 1963?
Your answer should be very brief. 5.22. 